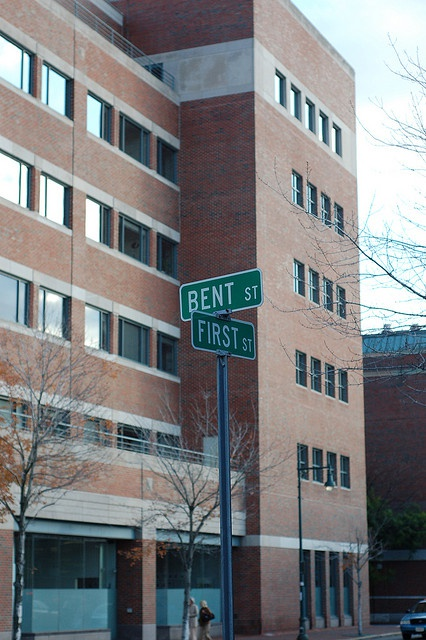Describe the objects in this image and their specific colors. I can see car in darkgray, black, blue, navy, and gray tones, people in darkgray, black, gray, blue, and darkblue tones, people in darkgray, gray, and purple tones, and handbag in black, darkblue, blue, and darkgray tones in this image. 